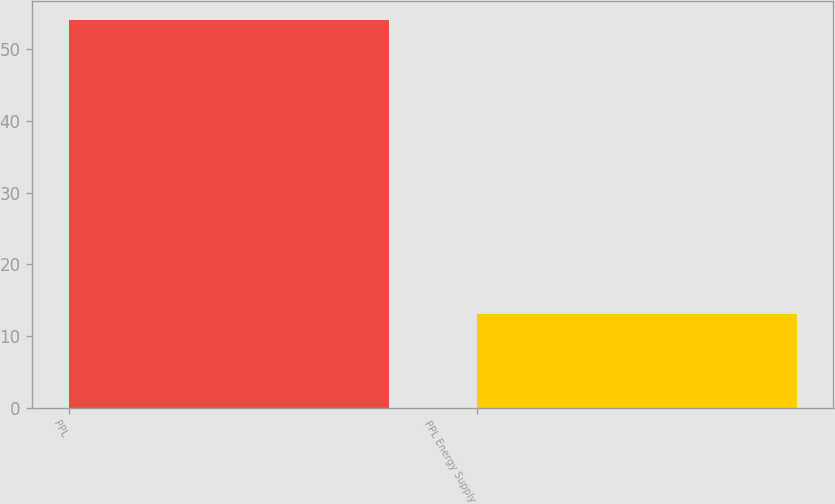Convert chart. <chart><loc_0><loc_0><loc_500><loc_500><bar_chart><fcel>PPL<fcel>PPL Energy Supply<nl><fcel>54<fcel>13<nl></chart> 